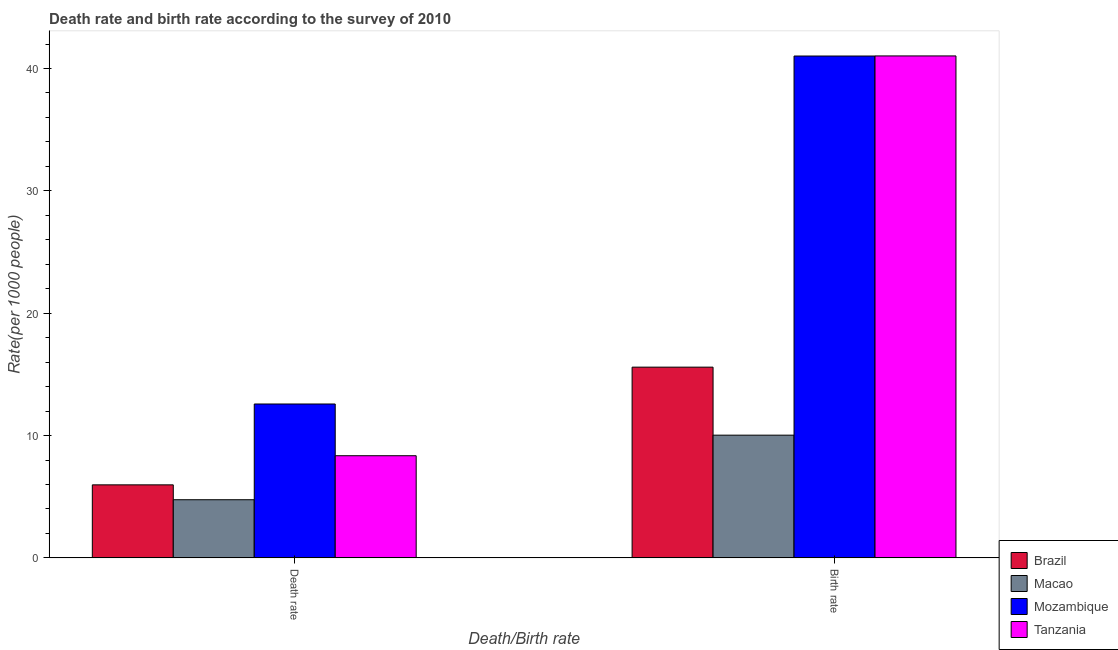How many different coloured bars are there?
Offer a very short reply. 4. How many bars are there on the 2nd tick from the left?
Provide a succinct answer. 4. How many bars are there on the 1st tick from the right?
Your response must be concise. 4. What is the label of the 2nd group of bars from the left?
Give a very brief answer. Birth rate. What is the birth rate in Tanzania?
Your response must be concise. 41.03. Across all countries, what is the maximum death rate?
Ensure brevity in your answer.  12.58. Across all countries, what is the minimum death rate?
Your response must be concise. 4.75. In which country was the birth rate maximum?
Your response must be concise. Tanzania. In which country was the death rate minimum?
Offer a very short reply. Macao. What is the total birth rate in the graph?
Keep it short and to the point. 107.67. What is the difference between the death rate in Tanzania and that in Mozambique?
Your answer should be very brief. -4.23. What is the difference between the birth rate in Macao and the death rate in Brazil?
Make the answer very short. 4.06. What is the average birth rate per country?
Provide a short and direct response. 26.92. What is the difference between the death rate and birth rate in Macao?
Make the answer very short. -5.28. In how many countries, is the death rate greater than 18 ?
Your response must be concise. 0. What is the ratio of the death rate in Brazil to that in Mozambique?
Provide a short and direct response. 0.47. In how many countries, is the death rate greater than the average death rate taken over all countries?
Provide a succinct answer. 2. What does the 1st bar from the left in Birth rate represents?
Your answer should be compact. Brazil. What does the 4th bar from the right in Birth rate represents?
Your answer should be very brief. Brazil. How many bars are there?
Offer a terse response. 8. Are all the bars in the graph horizontal?
Offer a very short reply. No. How many countries are there in the graph?
Provide a succinct answer. 4. What is the difference between two consecutive major ticks on the Y-axis?
Offer a terse response. 10. Are the values on the major ticks of Y-axis written in scientific E-notation?
Provide a succinct answer. No. Does the graph contain any zero values?
Your answer should be very brief. No. Does the graph contain grids?
Offer a very short reply. No. Where does the legend appear in the graph?
Your answer should be very brief. Bottom right. What is the title of the graph?
Give a very brief answer. Death rate and birth rate according to the survey of 2010. What is the label or title of the X-axis?
Your answer should be very brief. Death/Birth rate. What is the label or title of the Y-axis?
Give a very brief answer. Rate(per 1000 people). What is the Rate(per 1000 people) of Brazil in Death rate?
Provide a succinct answer. 5.97. What is the Rate(per 1000 people) of Macao in Death rate?
Your response must be concise. 4.75. What is the Rate(per 1000 people) in Mozambique in Death rate?
Your answer should be compact. 12.58. What is the Rate(per 1000 people) in Tanzania in Death rate?
Your answer should be compact. 8.35. What is the Rate(per 1000 people) of Brazil in Birth rate?
Your answer should be very brief. 15.59. What is the Rate(per 1000 people) in Macao in Birth rate?
Provide a short and direct response. 10.03. What is the Rate(per 1000 people) of Mozambique in Birth rate?
Give a very brief answer. 41.02. What is the Rate(per 1000 people) in Tanzania in Birth rate?
Your response must be concise. 41.03. Across all Death/Birth rate, what is the maximum Rate(per 1000 people) in Brazil?
Your response must be concise. 15.59. Across all Death/Birth rate, what is the maximum Rate(per 1000 people) in Macao?
Your answer should be very brief. 10.03. Across all Death/Birth rate, what is the maximum Rate(per 1000 people) of Mozambique?
Keep it short and to the point. 41.02. Across all Death/Birth rate, what is the maximum Rate(per 1000 people) of Tanzania?
Your answer should be very brief. 41.03. Across all Death/Birth rate, what is the minimum Rate(per 1000 people) of Brazil?
Provide a succinct answer. 5.97. Across all Death/Birth rate, what is the minimum Rate(per 1000 people) of Macao?
Provide a short and direct response. 4.75. Across all Death/Birth rate, what is the minimum Rate(per 1000 people) of Mozambique?
Ensure brevity in your answer.  12.58. Across all Death/Birth rate, what is the minimum Rate(per 1000 people) of Tanzania?
Your answer should be compact. 8.35. What is the total Rate(per 1000 people) of Brazil in the graph?
Make the answer very short. 21.56. What is the total Rate(per 1000 people) of Macao in the graph?
Provide a short and direct response. 14.79. What is the total Rate(per 1000 people) of Mozambique in the graph?
Provide a short and direct response. 53.6. What is the total Rate(per 1000 people) in Tanzania in the graph?
Offer a terse response. 49.38. What is the difference between the Rate(per 1000 people) of Brazil in Death rate and that in Birth rate?
Keep it short and to the point. -9.62. What is the difference between the Rate(per 1000 people) in Macao in Death rate and that in Birth rate?
Your response must be concise. -5.28. What is the difference between the Rate(per 1000 people) in Mozambique in Death rate and that in Birth rate?
Make the answer very short. -28.44. What is the difference between the Rate(per 1000 people) of Tanzania in Death rate and that in Birth rate?
Make the answer very short. -32.68. What is the difference between the Rate(per 1000 people) of Brazil in Death rate and the Rate(per 1000 people) of Macao in Birth rate?
Your answer should be very brief. -4.06. What is the difference between the Rate(per 1000 people) of Brazil in Death rate and the Rate(per 1000 people) of Mozambique in Birth rate?
Your response must be concise. -35.05. What is the difference between the Rate(per 1000 people) in Brazil in Death rate and the Rate(per 1000 people) in Tanzania in Birth rate?
Make the answer very short. -35.06. What is the difference between the Rate(per 1000 people) of Macao in Death rate and the Rate(per 1000 people) of Mozambique in Birth rate?
Provide a short and direct response. -36.27. What is the difference between the Rate(per 1000 people) of Macao in Death rate and the Rate(per 1000 people) of Tanzania in Birth rate?
Offer a terse response. -36.27. What is the difference between the Rate(per 1000 people) in Mozambique in Death rate and the Rate(per 1000 people) in Tanzania in Birth rate?
Offer a terse response. -28.45. What is the average Rate(per 1000 people) in Brazil per Death/Birth rate?
Your answer should be compact. 10.78. What is the average Rate(per 1000 people) in Macao per Death/Birth rate?
Give a very brief answer. 7.39. What is the average Rate(per 1000 people) of Mozambique per Death/Birth rate?
Offer a very short reply. 26.8. What is the average Rate(per 1000 people) in Tanzania per Death/Birth rate?
Provide a short and direct response. 24.69. What is the difference between the Rate(per 1000 people) of Brazil and Rate(per 1000 people) of Macao in Death rate?
Give a very brief answer. 1.22. What is the difference between the Rate(per 1000 people) in Brazil and Rate(per 1000 people) in Mozambique in Death rate?
Provide a succinct answer. -6.61. What is the difference between the Rate(per 1000 people) in Brazil and Rate(per 1000 people) in Tanzania in Death rate?
Provide a short and direct response. -2.38. What is the difference between the Rate(per 1000 people) in Macao and Rate(per 1000 people) in Mozambique in Death rate?
Your response must be concise. -7.83. What is the difference between the Rate(per 1000 people) in Macao and Rate(per 1000 people) in Tanzania in Death rate?
Keep it short and to the point. -3.6. What is the difference between the Rate(per 1000 people) of Mozambique and Rate(per 1000 people) of Tanzania in Death rate?
Your response must be concise. 4.23. What is the difference between the Rate(per 1000 people) in Brazil and Rate(per 1000 people) in Macao in Birth rate?
Keep it short and to the point. 5.56. What is the difference between the Rate(per 1000 people) in Brazil and Rate(per 1000 people) in Mozambique in Birth rate?
Give a very brief answer. -25.43. What is the difference between the Rate(per 1000 people) of Brazil and Rate(per 1000 people) of Tanzania in Birth rate?
Ensure brevity in your answer.  -25.44. What is the difference between the Rate(per 1000 people) in Macao and Rate(per 1000 people) in Mozambique in Birth rate?
Offer a terse response. -30.99. What is the difference between the Rate(per 1000 people) in Macao and Rate(per 1000 people) in Tanzania in Birth rate?
Offer a very short reply. -31. What is the difference between the Rate(per 1000 people) of Mozambique and Rate(per 1000 people) of Tanzania in Birth rate?
Offer a terse response. -0.01. What is the ratio of the Rate(per 1000 people) of Brazil in Death rate to that in Birth rate?
Give a very brief answer. 0.38. What is the ratio of the Rate(per 1000 people) in Macao in Death rate to that in Birth rate?
Keep it short and to the point. 0.47. What is the ratio of the Rate(per 1000 people) of Mozambique in Death rate to that in Birth rate?
Offer a terse response. 0.31. What is the ratio of the Rate(per 1000 people) in Tanzania in Death rate to that in Birth rate?
Ensure brevity in your answer.  0.2. What is the difference between the highest and the second highest Rate(per 1000 people) of Brazil?
Keep it short and to the point. 9.62. What is the difference between the highest and the second highest Rate(per 1000 people) in Macao?
Keep it short and to the point. 5.28. What is the difference between the highest and the second highest Rate(per 1000 people) of Mozambique?
Your answer should be compact. 28.44. What is the difference between the highest and the second highest Rate(per 1000 people) in Tanzania?
Your response must be concise. 32.68. What is the difference between the highest and the lowest Rate(per 1000 people) in Brazil?
Ensure brevity in your answer.  9.62. What is the difference between the highest and the lowest Rate(per 1000 people) in Macao?
Provide a short and direct response. 5.28. What is the difference between the highest and the lowest Rate(per 1000 people) in Mozambique?
Your answer should be compact. 28.44. What is the difference between the highest and the lowest Rate(per 1000 people) in Tanzania?
Your answer should be compact. 32.68. 